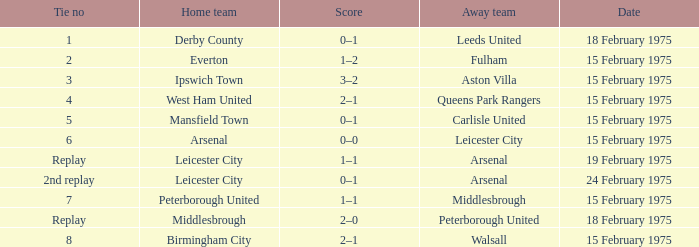On which date was the away team carlisle united? 15 February 1975. 